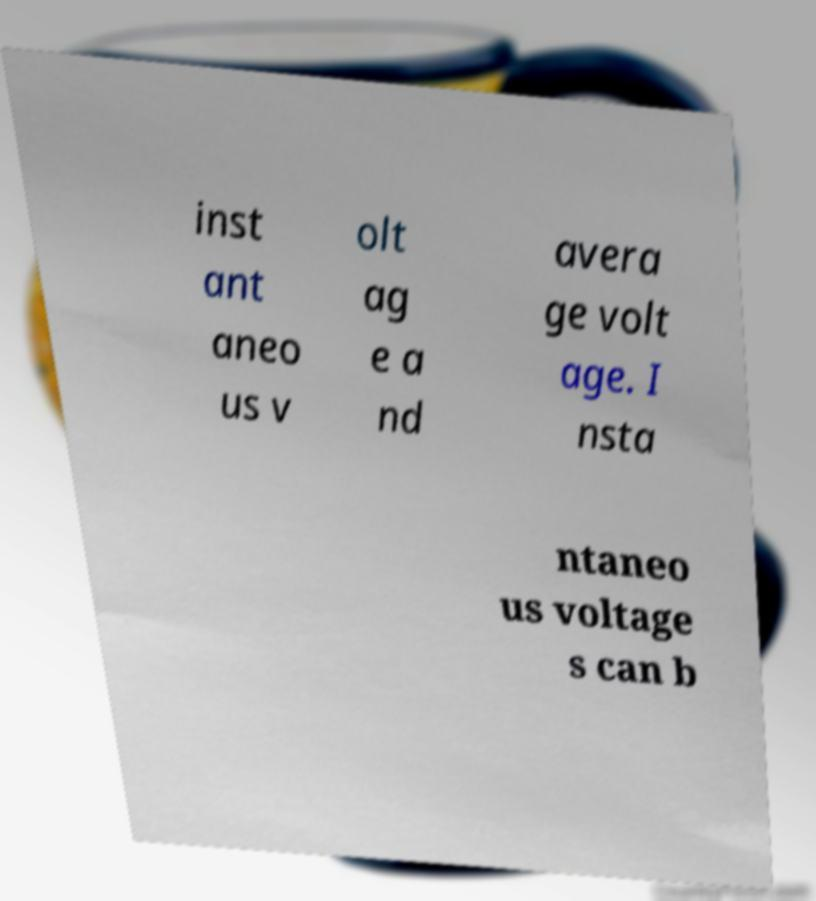There's text embedded in this image that I need extracted. Can you transcribe it verbatim? inst ant aneo us v olt ag e a nd avera ge volt age. I nsta ntaneo us voltage s can b 